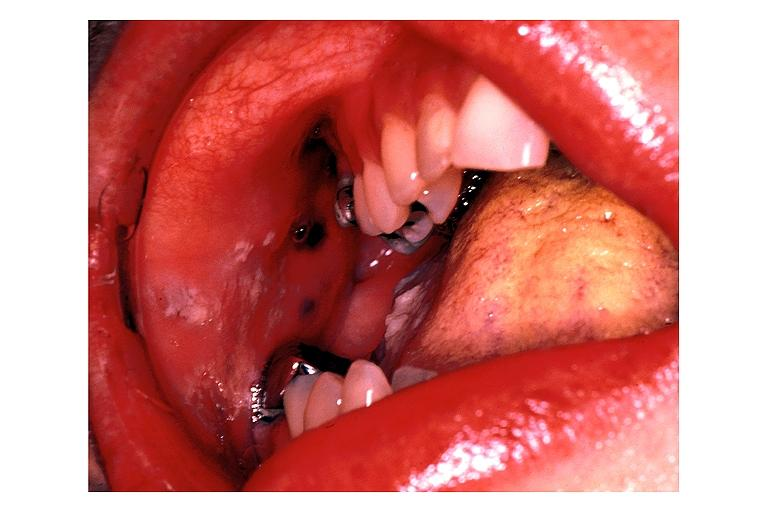what is present?
Answer the question using a single word or phrase. Oral 